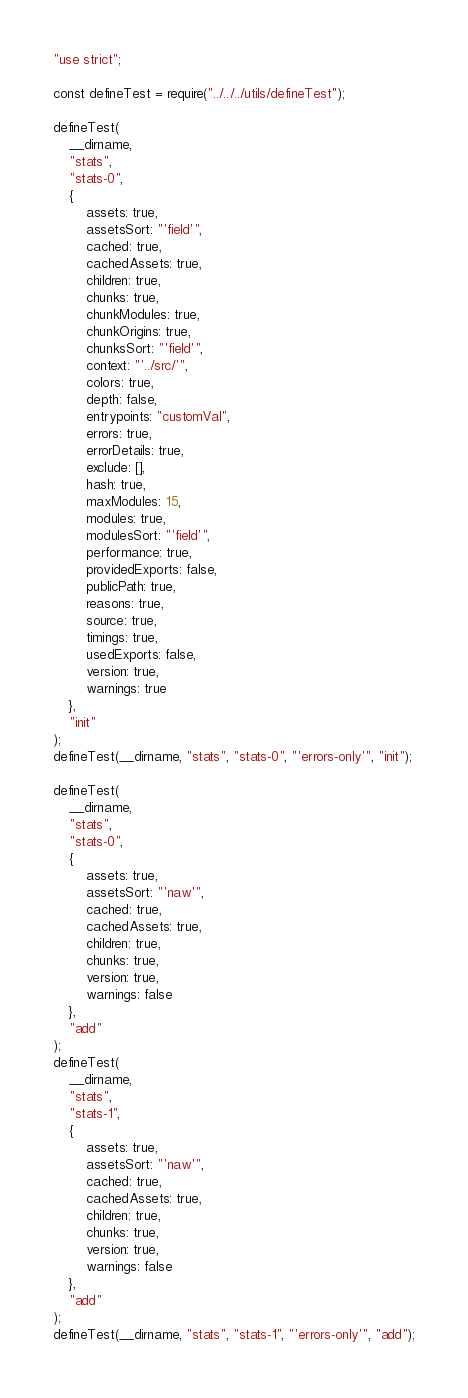<code> <loc_0><loc_0><loc_500><loc_500><_JavaScript_>"use strict";

const defineTest = require("../../../utils/defineTest");

defineTest(
	__dirname,
	"stats",
	"stats-0",
	{
		assets: true,
		assetsSort: "'field'",
		cached: true,
		cachedAssets: true,
		children: true,
		chunks: true,
		chunkModules: true,
		chunkOrigins: true,
		chunksSort: "'field'",
		context: "'../src/'",
		colors: true,
		depth: false,
		entrypoints: "customVal",
		errors: true,
		errorDetails: true,
		exclude: [],
		hash: true,
		maxModules: 15,
		modules: true,
		modulesSort: "'field'",
		performance: true,
		providedExports: false,
		publicPath: true,
		reasons: true,
		source: true,
		timings: true,
		usedExports: false,
		version: true,
		warnings: true
	},
	"init"
);
defineTest(__dirname, "stats", "stats-0", "'errors-only'", "init");

defineTest(
	__dirname,
	"stats",
	"stats-0",
	{
		assets: true,
		assetsSort: "'naw'",
		cached: true,
		cachedAssets: true,
		children: true,
		chunks: true,
		version: true,
		warnings: false
	},
	"add"
);
defineTest(
	__dirname,
	"stats",
	"stats-1",
	{
		assets: true,
		assetsSort: "'naw'",
		cached: true,
		cachedAssets: true,
		children: true,
		chunks: true,
		version: true,
		warnings: false
	},
	"add"
);
defineTest(__dirname, "stats", "stats-1", "'errors-only'", "add");
</code> 